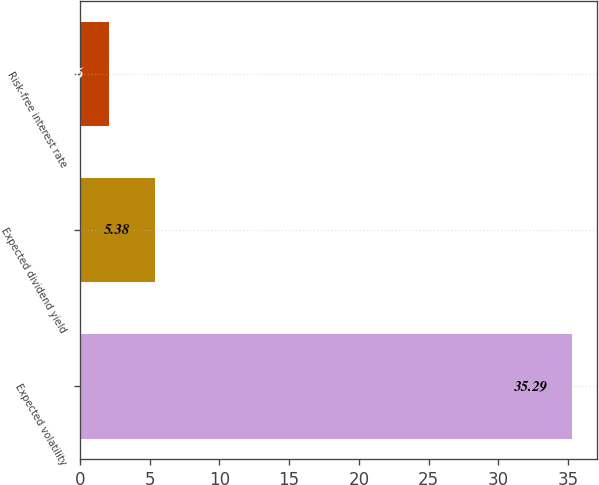Convert chart to OTSL. <chart><loc_0><loc_0><loc_500><loc_500><bar_chart><fcel>Expected volatility<fcel>Expected dividend yield<fcel>Risk-free interest rate<nl><fcel>35.29<fcel>5.38<fcel>2.06<nl></chart> 